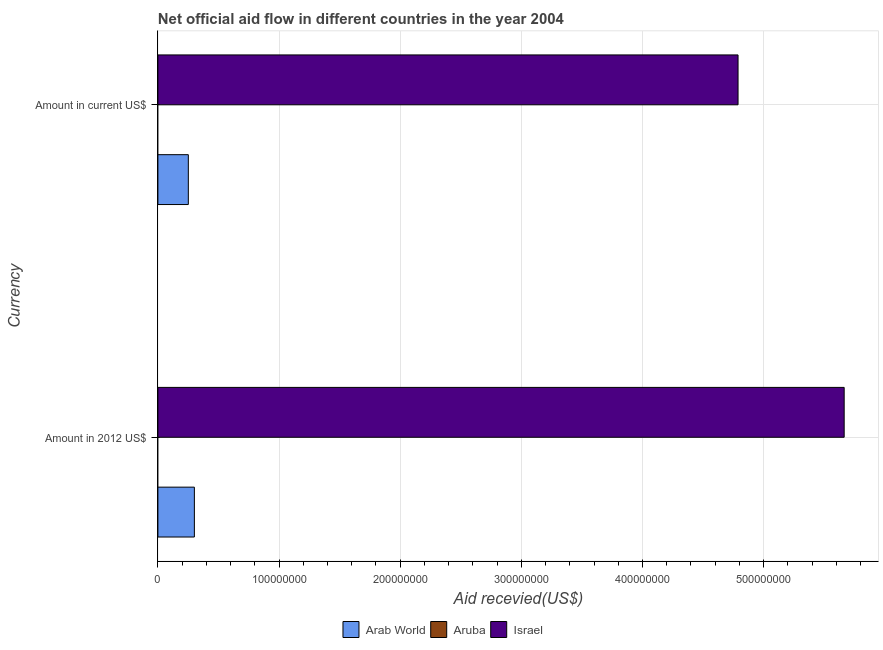Are the number of bars per tick equal to the number of legend labels?
Offer a very short reply. No. Are the number of bars on each tick of the Y-axis equal?
Make the answer very short. Yes. How many bars are there on the 1st tick from the top?
Provide a succinct answer. 2. How many bars are there on the 1st tick from the bottom?
Give a very brief answer. 2. What is the label of the 1st group of bars from the top?
Give a very brief answer. Amount in current US$. What is the amount of aid received(expressed in 2012 us$) in Israel?
Your answer should be compact. 5.66e+08. Across all countries, what is the maximum amount of aid received(expressed in 2012 us$)?
Make the answer very short. 5.66e+08. Across all countries, what is the minimum amount of aid received(expressed in us$)?
Your answer should be compact. 0. In which country was the amount of aid received(expressed in us$) maximum?
Keep it short and to the point. Israel. What is the total amount of aid received(expressed in us$) in the graph?
Ensure brevity in your answer.  5.04e+08. What is the difference between the amount of aid received(expressed in us$) in Arab World and that in Israel?
Offer a very short reply. -4.54e+08. What is the difference between the amount of aid received(expressed in 2012 us$) in Arab World and the amount of aid received(expressed in us$) in Israel?
Offer a very short reply. -4.49e+08. What is the average amount of aid received(expressed in us$) per country?
Ensure brevity in your answer.  1.68e+08. What is the difference between the amount of aid received(expressed in 2012 us$) and amount of aid received(expressed in us$) in Arab World?
Ensure brevity in your answer.  4.99e+06. In how many countries, is the amount of aid received(expressed in us$) greater than 300000000 US$?
Your response must be concise. 1. What is the ratio of the amount of aid received(expressed in 2012 us$) in Arab World to that in Israel?
Give a very brief answer. 0.05. Are all the bars in the graph horizontal?
Make the answer very short. Yes. Are the values on the major ticks of X-axis written in scientific E-notation?
Your answer should be very brief. No. Does the graph contain any zero values?
Offer a terse response. Yes. What is the title of the graph?
Provide a succinct answer. Net official aid flow in different countries in the year 2004. Does "Spain" appear as one of the legend labels in the graph?
Provide a short and direct response. No. What is the label or title of the X-axis?
Your response must be concise. Aid recevied(US$). What is the label or title of the Y-axis?
Your response must be concise. Currency. What is the Aid recevied(US$) of Arab World in Amount in 2012 US$?
Offer a terse response. 3.01e+07. What is the Aid recevied(US$) of Aruba in Amount in 2012 US$?
Your answer should be very brief. 0. What is the Aid recevied(US$) of Israel in Amount in 2012 US$?
Keep it short and to the point. 5.66e+08. What is the Aid recevied(US$) in Arab World in Amount in current US$?
Offer a terse response. 2.51e+07. What is the Aid recevied(US$) of Aruba in Amount in current US$?
Your answer should be very brief. 0. What is the Aid recevied(US$) of Israel in Amount in current US$?
Provide a succinct answer. 4.79e+08. Across all Currency, what is the maximum Aid recevied(US$) of Arab World?
Provide a succinct answer. 3.01e+07. Across all Currency, what is the maximum Aid recevied(US$) in Israel?
Offer a terse response. 5.66e+08. Across all Currency, what is the minimum Aid recevied(US$) of Arab World?
Offer a very short reply. 2.51e+07. Across all Currency, what is the minimum Aid recevied(US$) of Israel?
Keep it short and to the point. 4.79e+08. What is the total Aid recevied(US$) in Arab World in the graph?
Give a very brief answer. 5.52e+07. What is the total Aid recevied(US$) of Aruba in the graph?
Make the answer very short. 0. What is the total Aid recevied(US$) in Israel in the graph?
Keep it short and to the point. 1.05e+09. What is the difference between the Aid recevied(US$) in Arab World in Amount in 2012 US$ and that in Amount in current US$?
Your answer should be very brief. 4.99e+06. What is the difference between the Aid recevied(US$) of Israel in Amount in 2012 US$ and that in Amount in current US$?
Make the answer very short. 8.76e+07. What is the difference between the Aid recevied(US$) of Arab World in Amount in 2012 US$ and the Aid recevied(US$) of Israel in Amount in current US$?
Make the answer very short. -4.49e+08. What is the average Aid recevied(US$) of Arab World per Currency?
Your answer should be compact. 2.76e+07. What is the average Aid recevied(US$) in Aruba per Currency?
Ensure brevity in your answer.  0. What is the average Aid recevied(US$) in Israel per Currency?
Your answer should be compact. 5.23e+08. What is the difference between the Aid recevied(US$) of Arab World and Aid recevied(US$) of Israel in Amount in 2012 US$?
Your answer should be compact. -5.36e+08. What is the difference between the Aid recevied(US$) of Arab World and Aid recevied(US$) of Israel in Amount in current US$?
Provide a short and direct response. -4.54e+08. What is the ratio of the Aid recevied(US$) of Arab World in Amount in 2012 US$ to that in Amount in current US$?
Your answer should be compact. 1.2. What is the ratio of the Aid recevied(US$) in Israel in Amount in 2012 US$ to that in Amount in current US$?
Give a very brief answer. 1.18. What is the difference between the highest and the second highest Aid recevied(US$) of Arab World?
Provide a succinct answer. 4.99e+06. What is the difference between the highest and the second highest Aid recevied(US$) of Israel?
Ensure brevity in your answer.  8.76e+07. What is the difference between the highest and the lowest Aid recevied(US$) in Arab World?
Provide a short and direct response. 4.99e+06. What is the difference between the highest and the lowest Aid recevied(US$) of Israel?
Your answer should be very brief. 8.76e+07. 